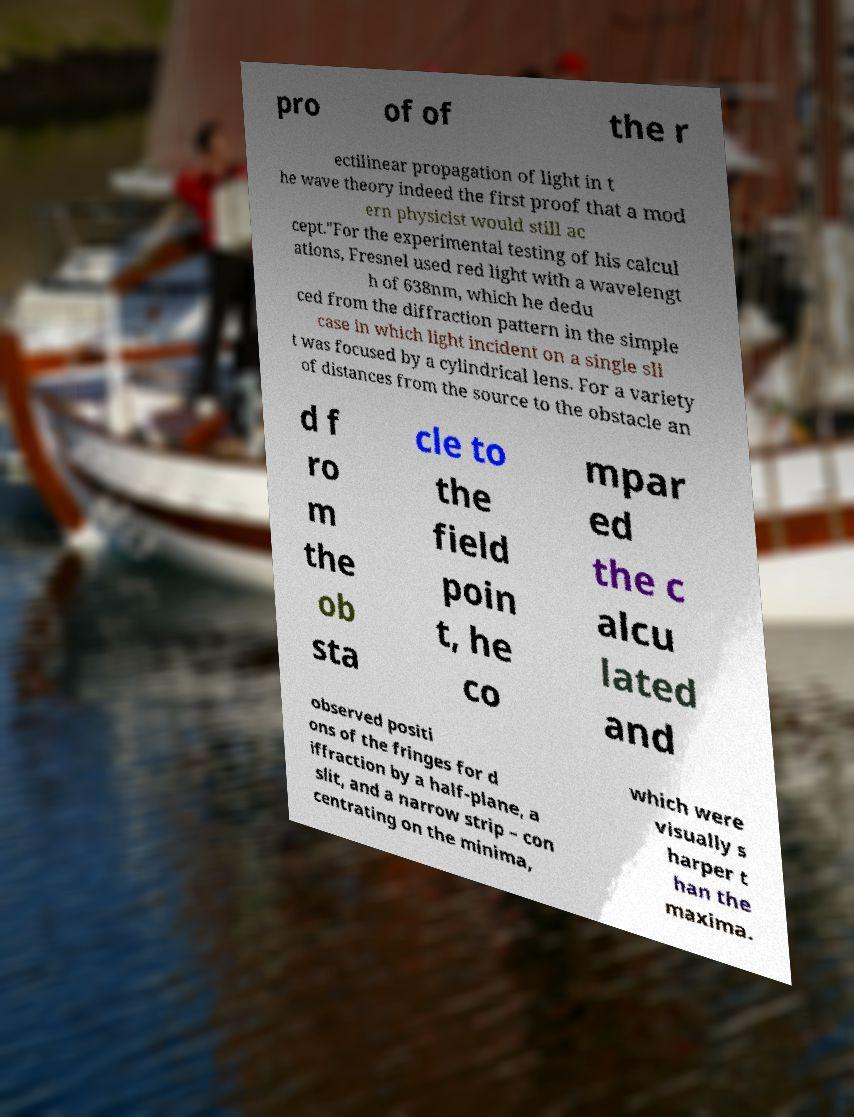Please identify and transcribe the text found in this image. pro of of the r ectilinear propagation of light in t he wave theory indeed the first proof that a mod ern physicist would still ac cept."For the experimental testing of his calcul ations, Fresnel used red light with a wavelengt h of 638nm, which he dedu ced from the diffraction pattern in the simple case in which light incident on a single sli t was focused by a cylindrical lens. For a variety of distances from the source to the obstacle an d f ro m the ob sta cle to the field poin t, he co mpar ed the c alcu lated and observed positi ons of the fringes for d iffraction by a half-plane, a slit, and a narrow strip – con centrating on the minima, which were visually s harper t han the maxima. 